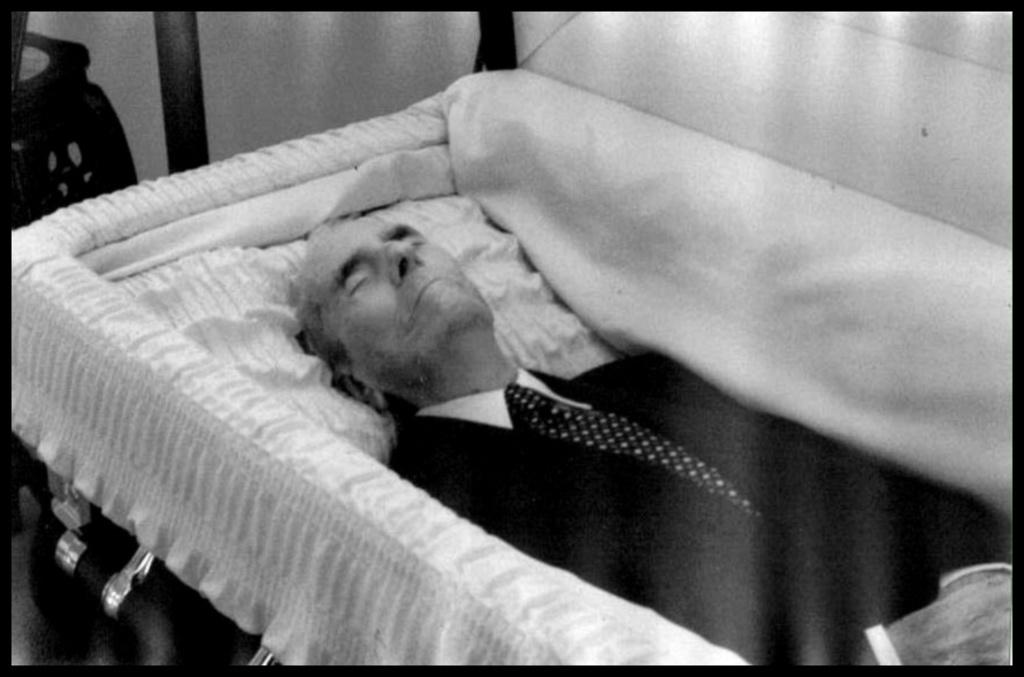What is the color scheme of the image? The image is black and white. What can be seen inside the casket in the image? There is an old man in the casket. What is the old man wearing in the image? The old man is wearing a white shirt and a black blazer. What is visible behind the casket in the image? There is a wall visible behind the casket. What type of rule is being enforced by the old man in the image? There is no indication of any rule being enforced in the image; it depicts an old man in a casket. Can you describe the sofa that the old man is sitting on in the image? There is no sofa present in the image; the old man is in a casket. 